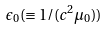<formula> <loc_0><loc_0><loc_500><loc_500>\epsilon _ { 0 } ( \equiv 1 / ( c ^ { 2 } \mu _ { 0 } ) )</formula> 